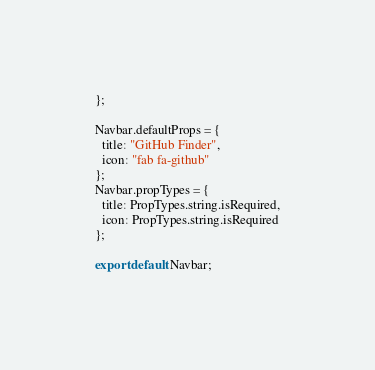Convert code to text. <code><loc_0><loc_0><loc_500><loc_500><_JavaScript_>};

Navbar.defaultProps = {
  title: "GitHub Finder",
  icon: "fab fa-github"
};
Navbar.propTypes = {
  title: PropTypes.string.isRequired,
  icon: PropTypes.string.isRequired
};

export default Navbar;
</code> 